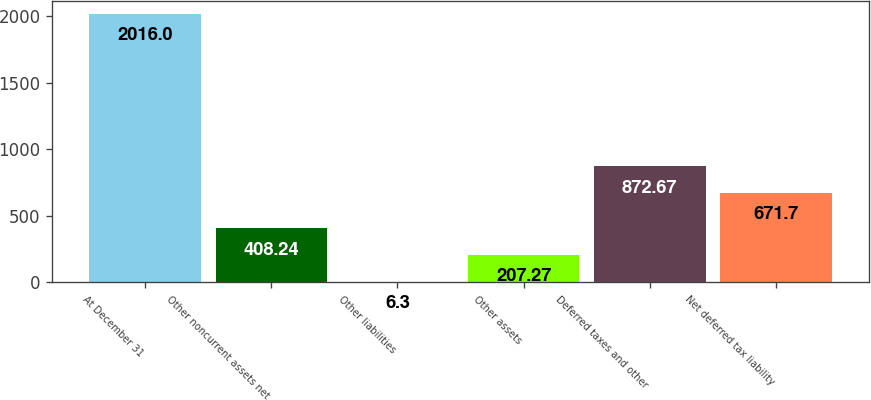Convert chart to OTSL. <chart><loc_0><loc_0><loc_500><loc_500><bar_chart><fcel>At December 31<fcel>Other noncurrent assets net<fcel>Other liabilities<fcel>Other assets<fcel>Deferred taxes and other<fcel>Net deferred tax liability<nl><fcel>2016<fcel>408.24<fcel>6.3<fcel>207.27<fcel>872.67<fcel>671.7<nl></chart> 